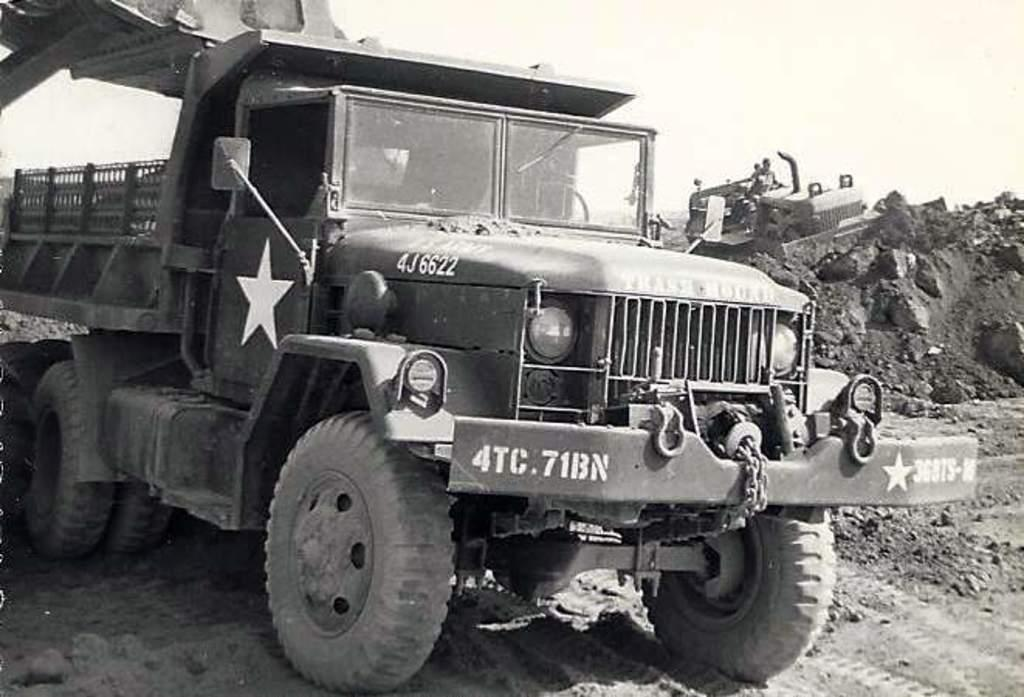What is the color scheme of the image? The image is black and white. What types of objects can be seen in the image? There are vehicles and rocks in the image. What is visible in the background of the image? The sky is visible in the background of the image. How does the image attempt to raise awareness about pollution? The image does not attempt to raise awareness about pollution, as it does not contain any elements related to pollution. 